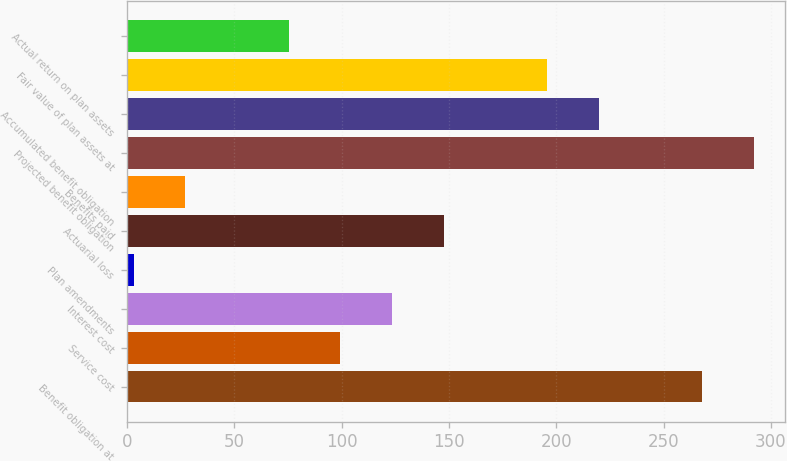Convert chart to OTSL. <chart><loc_0><loc_0><loc_500><loc_500><bar_chart><fcel>Benefit obligation at<fcel>Service cost<fcel>Interest cost<fcel>Plan amendments<fcel>Actuarial loss<fcel>Benefits paid<fcel>Projected benefit obligation<fcel>Accumulated benefit obligation<fcel>Fair value of plan assets at<fcel>Actual return on plan assets<nl><fcel>268.1<fcel>99.4<fcel>123.5<fcel>3<fcel>147.6<fcel>27.1<fcel>292.2<fcel>219.9<fcel>195.8<fcel>75.3<nl></chart> 